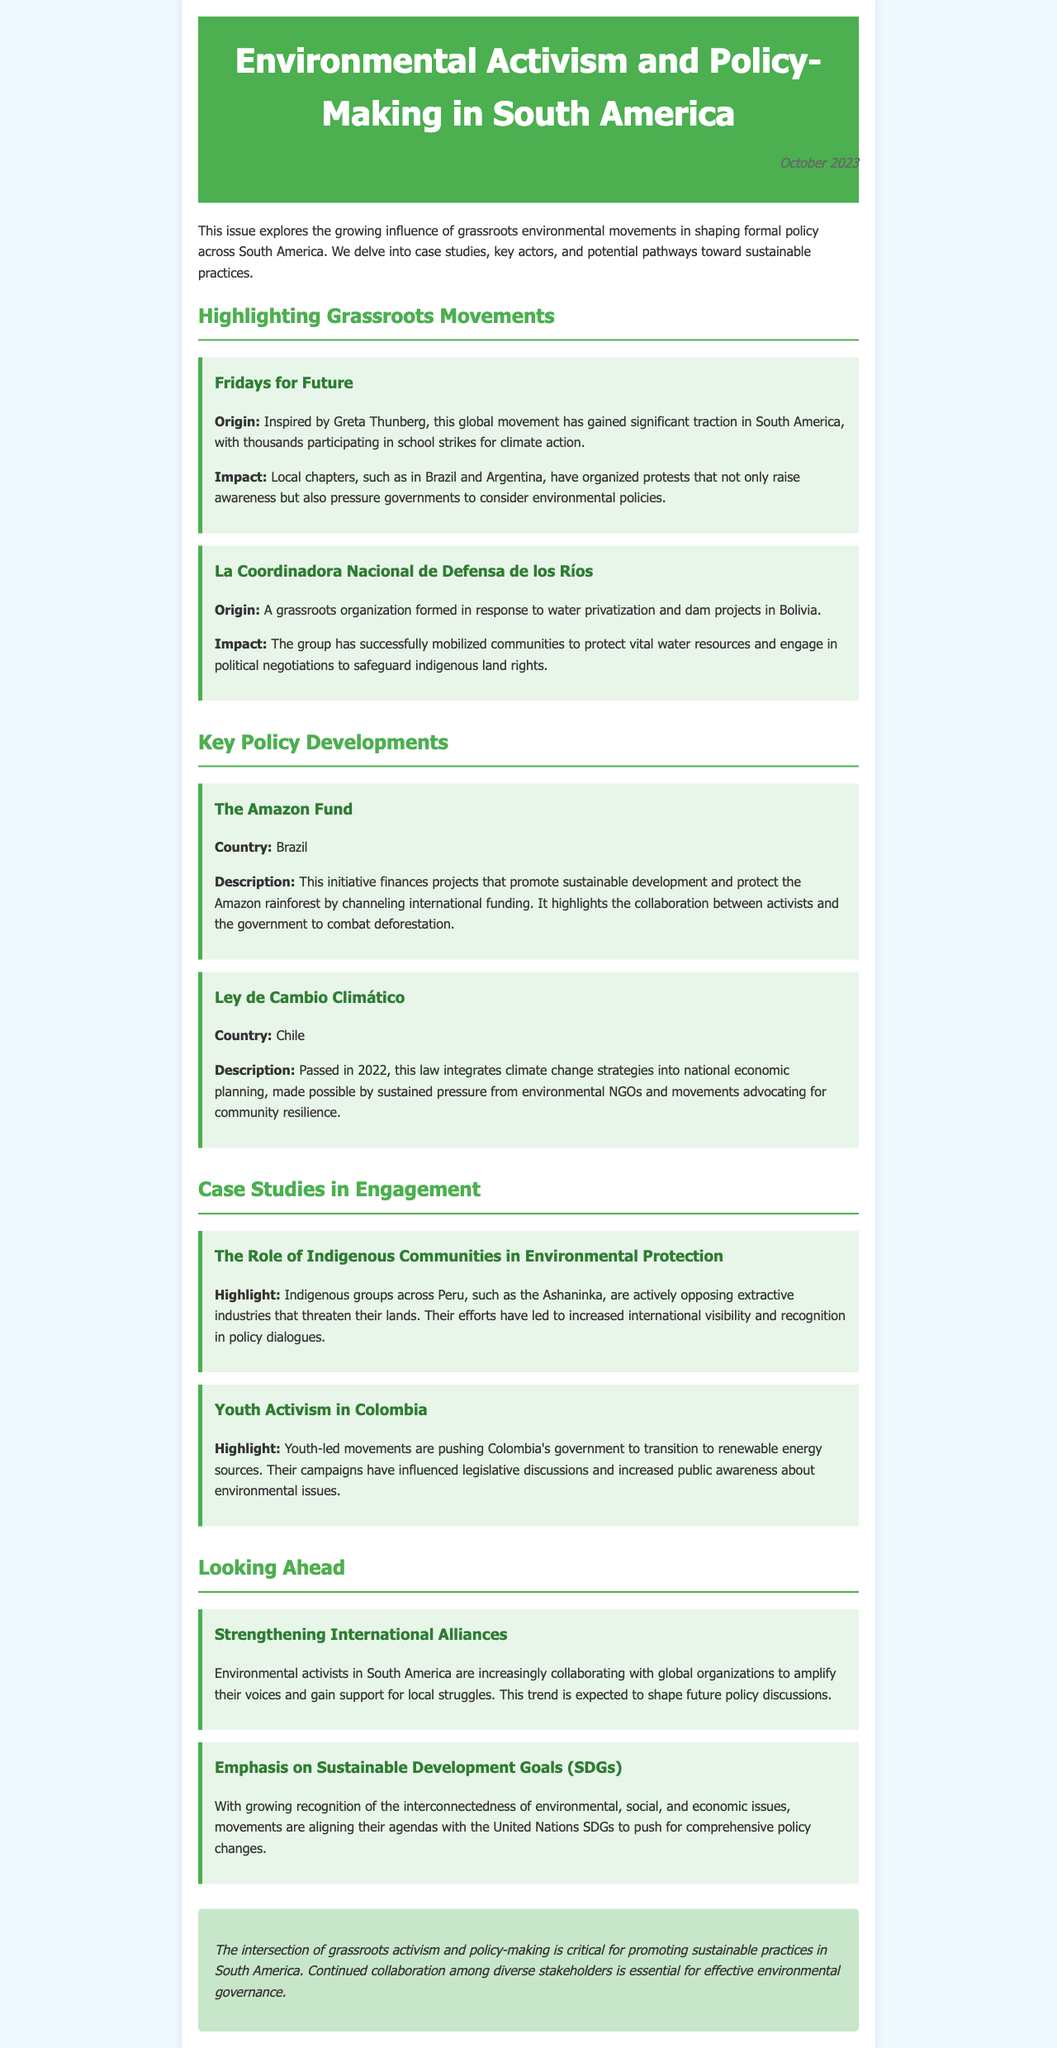what is the origin of Fridays for Future? Fridays for Future was inspired by Greta Thunberg, a global movement that has gained significant traction in South America.
Answer: Inspired by Greta Thunberg what is the focus of La Coordinadora Nacional de Defensa de los Ríos? La Coordinadora Nacional de Defensa de los Ríos focuses on protecting vital water resources and engaging in political negotiations regarding indigenous land rights.
Answer: Protecting vital water resources what is the Amazon Fund primarily aimed at? The Amazon Fund is aimed at financing projects that promote sustainable development and protect the Amazon rainforest.
Answer: Financing projects for sustainable development which law passed in 2022 integrates climate change strategies into national planning in Chile? The Ley de Cambio Climático, passed in 2022, integrates climate change strategies into national economic planning in Chile.
Answer: Ley de Cambio Climático which indigenous group in Peru is mentioned for their opposition to extractive industries? The Ashaninka is the indigenous group in Peru mentioned for their opposition to extractive industries.
Answer: Ashaninka how are environmental activists in South America expected to influence future policy? Environmental activists are expected to influence future policy by strengthening international alliances and collaborating with global organizations.
Answer: Strengthening international alliances which movement is highlighted for pushing Colombia's government towards renewable energy? Youth activism in Colombia is highlighted for pushing the government to transition to renewable energy sources.
Answer: Youth activism what is the overall theme of the document? The overall theme of the document is the intersection of grassroots activism and policy-making in promoting sustainable practices in South America.
Answer: Intersection of grassroots activism and policy-making 